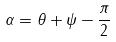<formula> <loc_0><loc_0><loc_500><loc_500>\alpha = \theta + \psi - \frac { \pi } { 2 }</formula> 